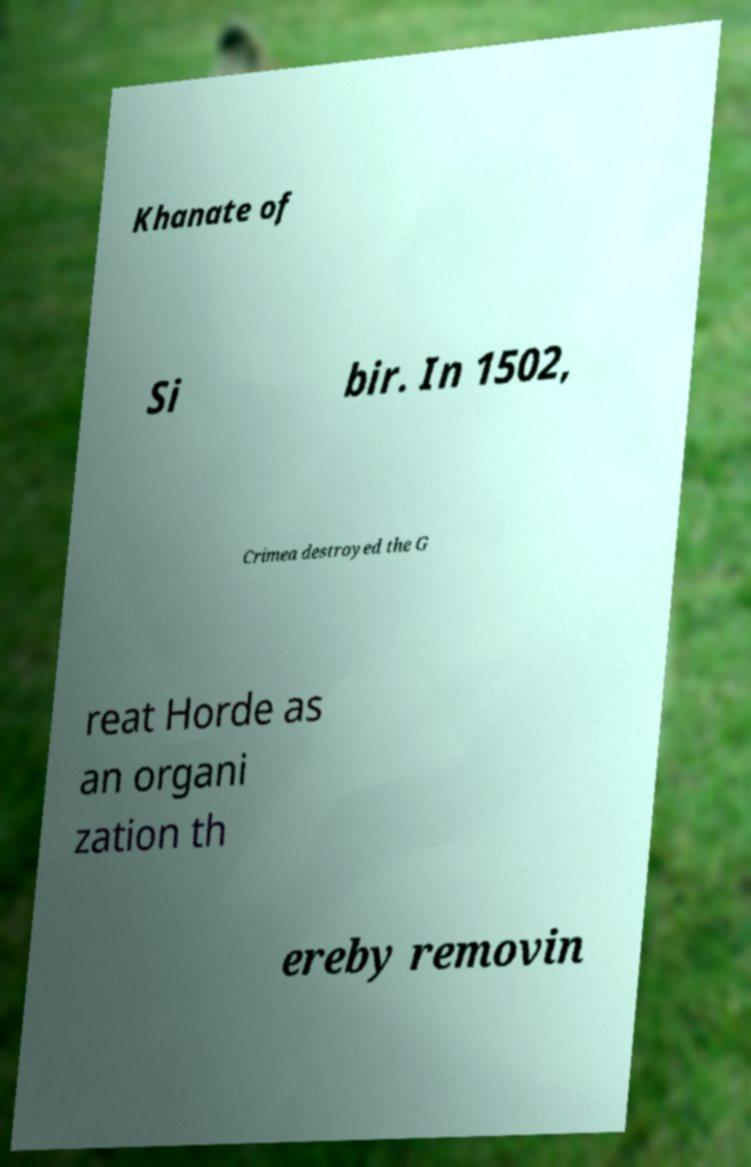Please identify and transcribe the text found in this image. Khanate of Si bir. In 1502, Crimea destroyed the G reat Horde as an organi zation th ereby removin 